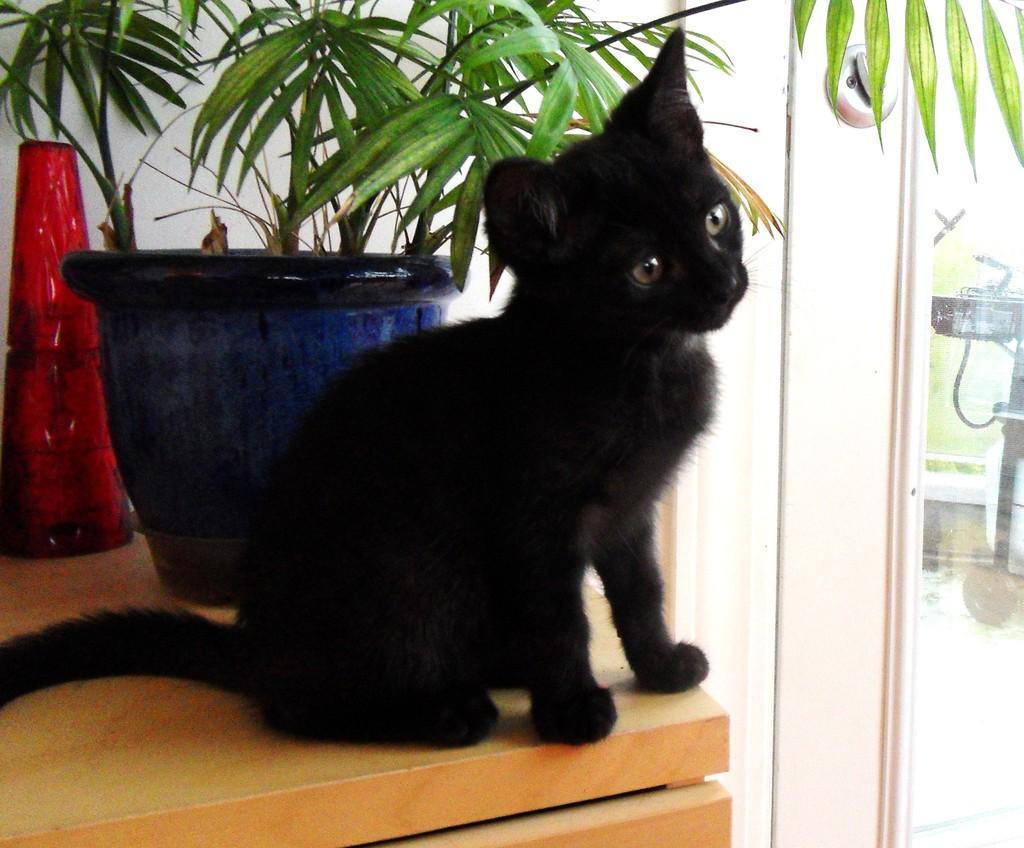What type of animal can be seen in the image? There is a black cat in the image. What other object is present in the image besides the cat? There is a houseplant in the image. How is the houseplant positioned in the image? The houseplant is on a wooden platform. What type of vegetation can be seen in the background of the image? There is grass visible in the background of the image. Can you describe the object in the background of the image? There is an object in the background of the image, but its specific details are not clear from the provided facts. What type of cord is being used by the cat to climb the houseplant in the image? There is no cord visible in the image, and the cat is not shown climbing the houseplant. 